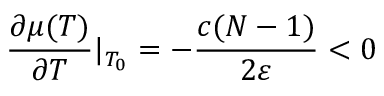<formula> <loc_0><loc_0><loc_500><loc_500>\frac { \partial \mu ( T ) } { \partial T } | _ { T _ { 0 } } = - \frac { c ( N - 1 ) } { 2 \varepsilon } < 0</formula> 